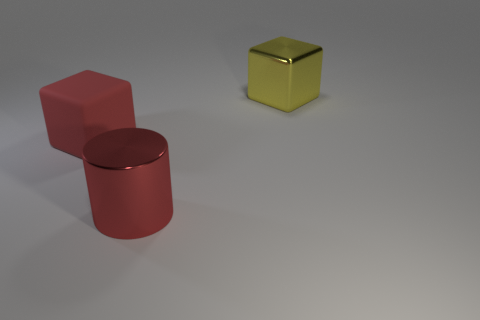What shape is the big red object that is behind the large metallic object left of the shiny object that is behind the big red matte cube?
Give a very brief answer. Cube. What is the object that is both behind the cylinder and to the right of the large rubber block made of?
Provide a short and direct response. Metal. There is a thing in front of the matte cube; does it have the same size as the big yellow metallic object?
Your answer should be compact. Yes. Are there any other things that are the same size as the yellow metal block?
Provide a short and direct response. Yes. Are there more cylinders in front of the red shiny object than red objects that are in front of the yellow metal cube?
Ensure brevity in your answer.  No. What is the color of the big cube that is right of the large red object to the left of the big metallic thing in front of the large yellow metallic thing?
Offer a very short reply. Yellow. Does the thing left of the big cylinder have the same color as the metallic cube?
Provide a succinct answer. No. What number of other things are the same color as the big rubber block?
Your answer should be compact. 1. What number of objects are either large red matte objects or purple metallic cylinders?
Keep it short and to the point. 1. How many objects are either red rubber blocks or objects on the left side of the red metal thing?
Provide a succinct answer. 1. 